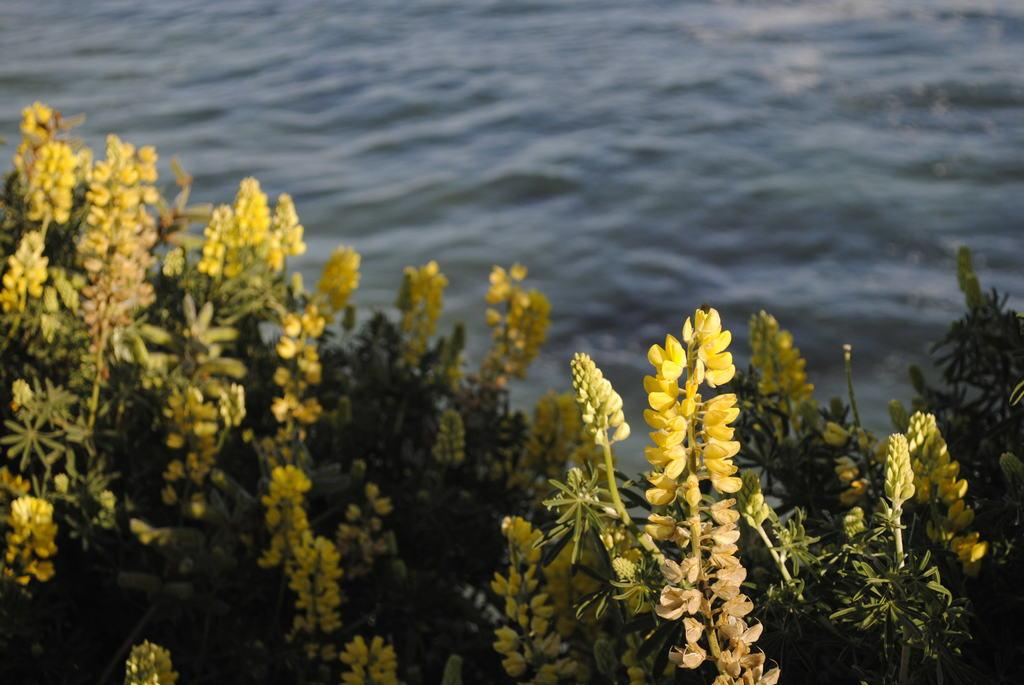What type of flowers can be seen in the image? There are yellow flowers in the image. What stage of growth are some of the flowers in? There are buds in the image. What color are the leaves in the image? There are green leaves in the image. What can be seen in the background of the image? There is water visible in the background of the image. How many pigs are visible in the image? There are no pigs present in the image. What type of net is used to catch the fish in the image? There is no net or fish present in the image, only water in the background. 